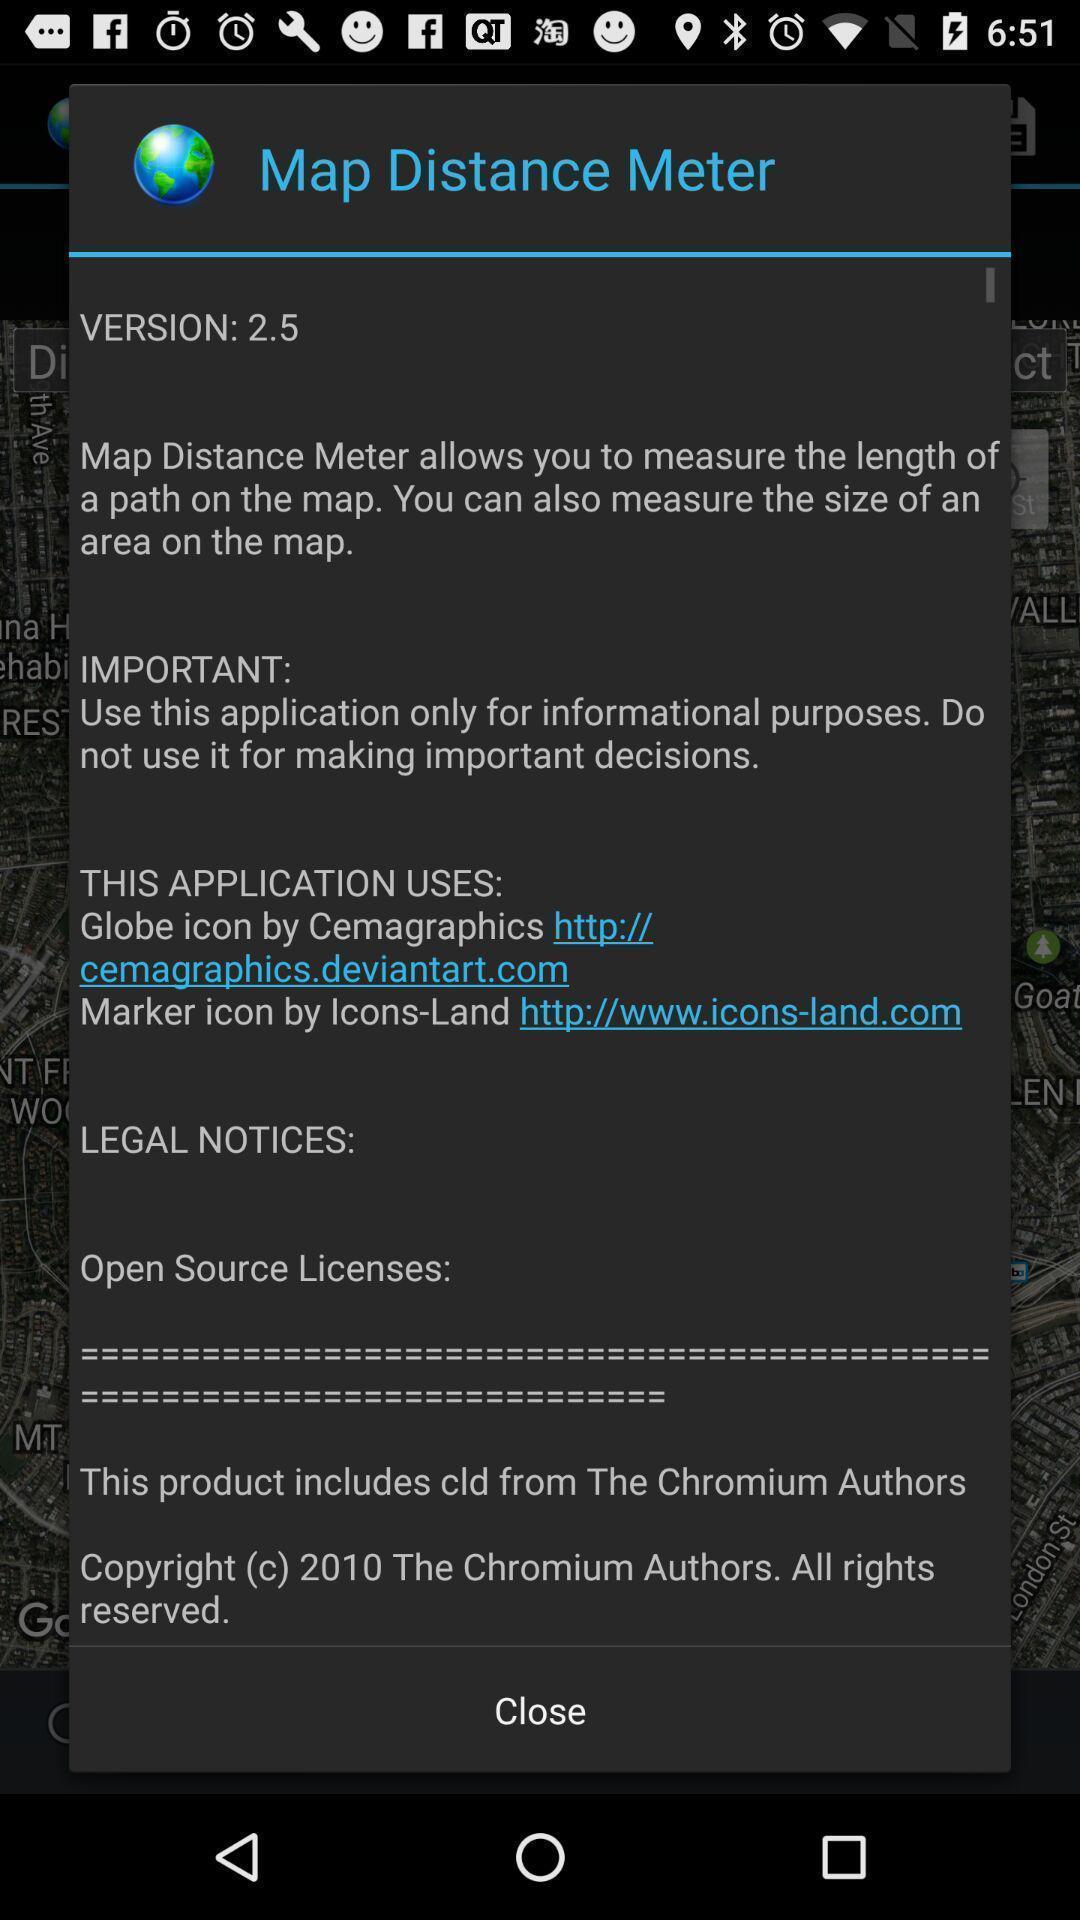Summarize the main components in this picture. Pop-up displaying information about the app. 